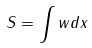Convert formula to latex. <formula><loc_0><loc_0><loc_500><loc_500>S = \int w d x</formula> 